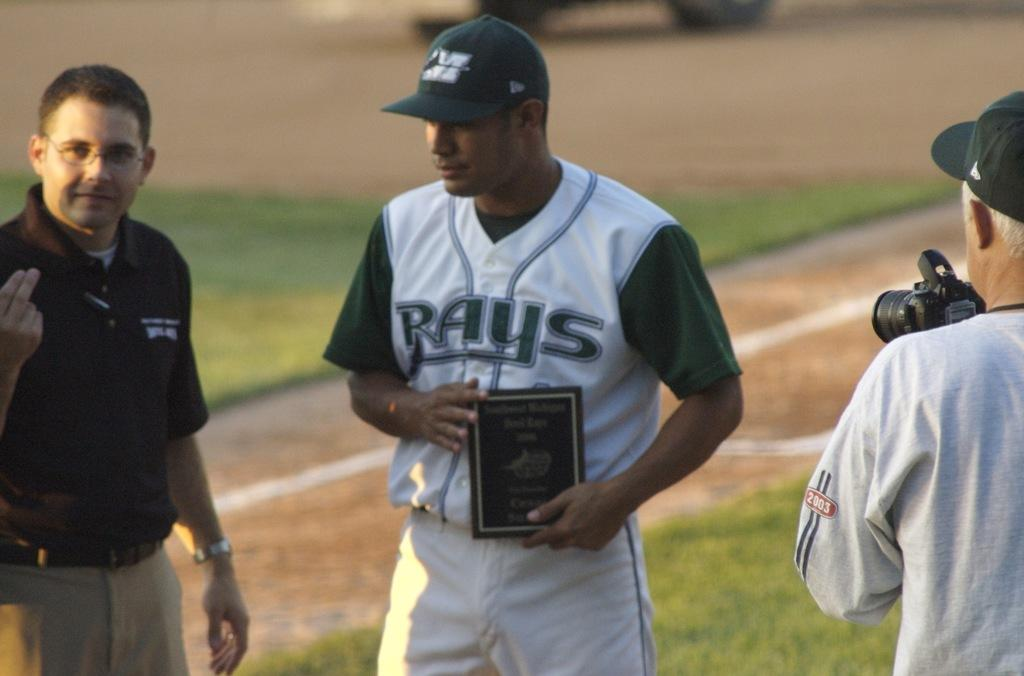<image>
Present a compact description of the photo's key features. A baseball player with the team RAYS on his shirt is holding something in his hands on the field with two other men there. 